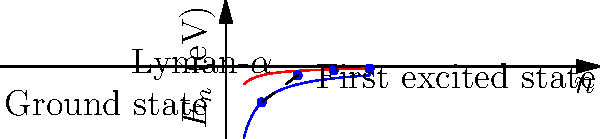Consider the energy levels of a hydrogen atom as described by the Bohr model. The graph shows the energy levels ($E_n$) as a function of the principal quantum number ($n$). The blue curve represents the actual energy levels, while the red curve represents a hypothetical energy function. Given that the ground state energy is -13.6 eV, what is the energy of the Lyman-$\alpha$ transition (from $n=2$ to $n=1$) in electron volts? Express your answer using the concept of group orbits in the energy level space. To solve this problem, we'll follow these steps:

1) First, recall the energy level formula for the hydrogen atom in the Bohr model:

   $$E_n = -\frac{13.6 \text{ eV}}{n^2}$$

2) We need to calculate the energies for $n=1$ (ground state) and $n=2$ (first excited state):

   For $n=1$: $E_1 = -\frac{13.6 \text{ eV}}{1^2} = -13.6 \text{ eV}$
   For $n=2$: $E_2 = -\frac{13.6 \text{ eV}}{2^2} = -3.4 \text{ eV}$

3) The Lyman-$\alpha$ transition is from $n=2$ to $n=1$. The energy of this transition is the difference between these two energy levels:

   $$\Delta E = E_1 - E_2 = -13.6 \text{ eV} - (-3.4 \text{ eV}) = -10.2 \text{ eV}$$

4) The negative sign indicates that this energy is released (emitted) during the transition.

5) Now, to express this in terms of group orbits, we can consider the group action of the multiplicative group of positive rationals $\mathbb{Q}^+$ on the set of energy levels. The orbit of the ground state energy under this action generates all possible energy levels:

   $$\text{Orbit}(-13.6 \text{ eV}) = \{-\frac{13.6 \text{ eV}}{n^2} : n \in \mathbb{N}\}$$

6) The Lyman-$\alpha$ transition energy can be expressed as the difference between two elements in this orbit:

   $$10.2 \text{ eV} = -13.6 \text{ eV} \cdot (1 - \frac{1}{4})$$

   This shows that the transition energy is also an element of the orbit, scaled by the factor $(1 - \frac{1}{4})$.
Answer: 10.2 eV, expressible as $-13.6 \text{ eV} \cdot (1 - \frac{1}{4})$ in the orbit of ground state energy 